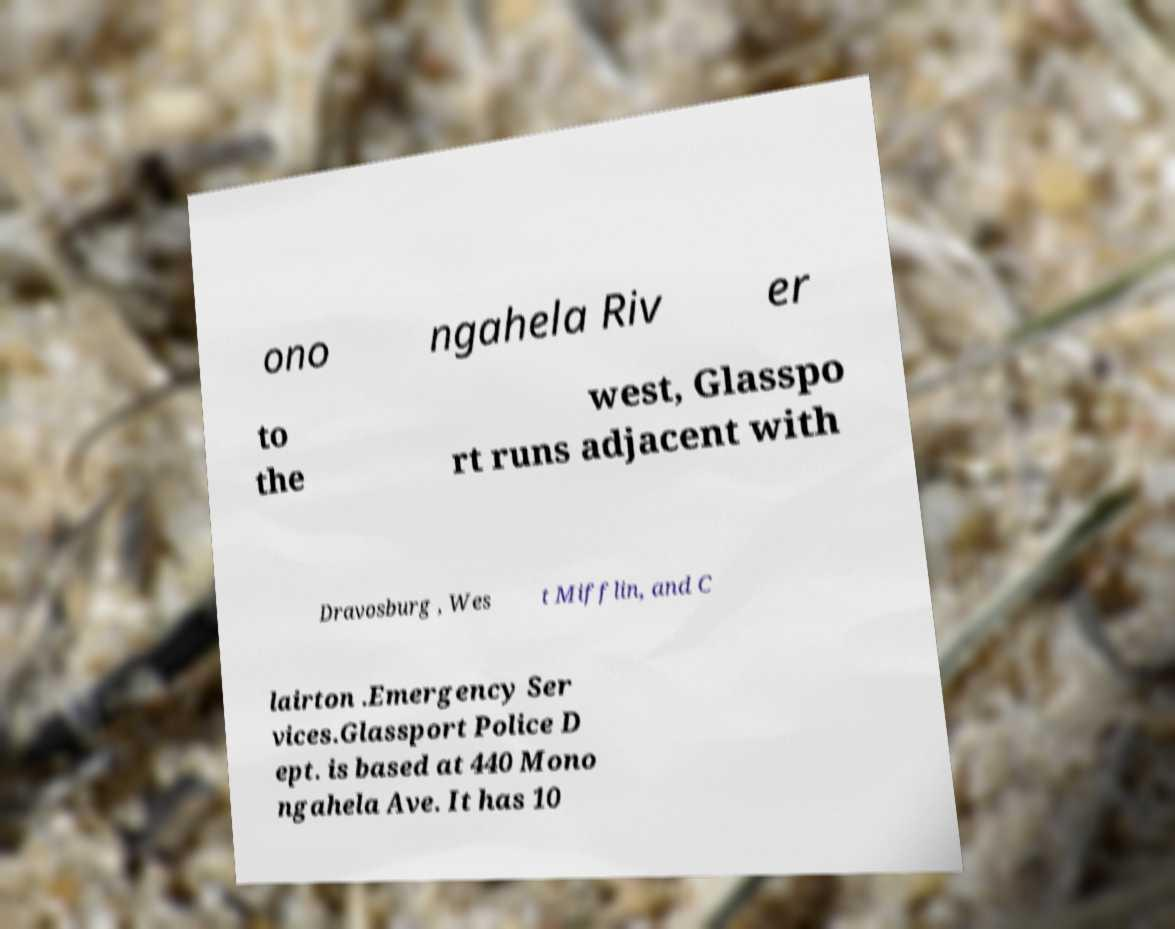Can you accurately transcribe the text from the provided image for me? ono ngahela Riv er to the west, Glasspo rt runs adjacent with Dravosburg , Wes t Mifflin, and C lairton .Emergency Ser vices.Glassport Police D ept. is based at 440 Mono ngahela Ave. It has 10 